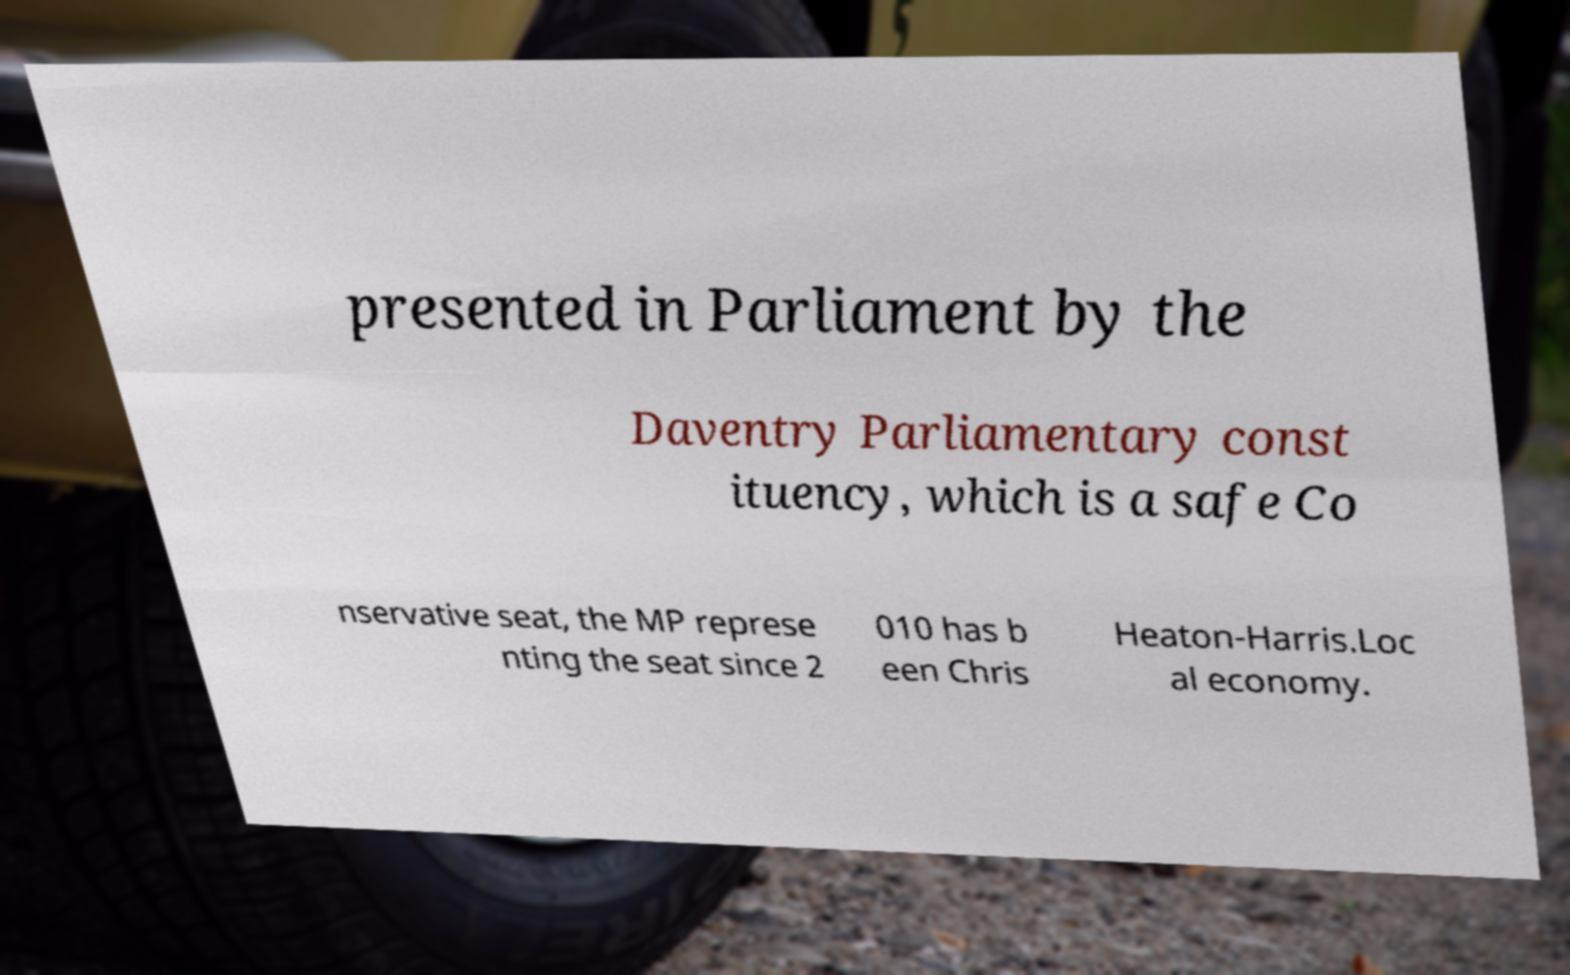Please identify and transcribe the text found in this image. presented in Parliament by the Daventry Parliamentary const ituency, which is a safe Co nservative seat, the MP represe nting the seat since 2 010 has b een Chris Heaton-Harris.Loc al economy. 